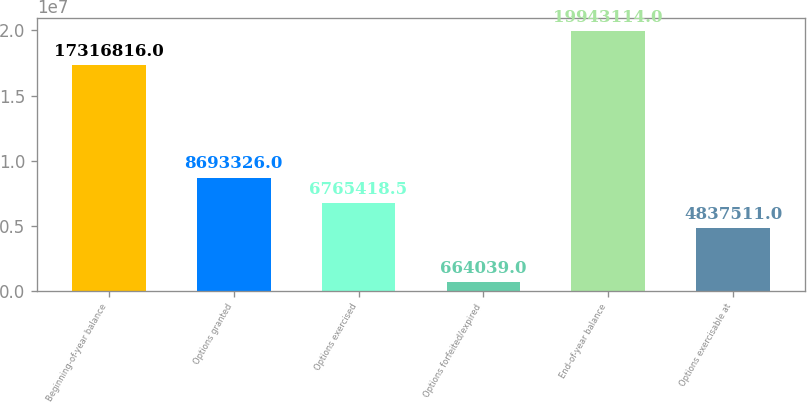<chart> <loc_0><loc_0><loc_500><loc_500><bar_chart><fcel>Beginning-of-year balance<fcel>Options granted<fcel>Options exercised<fcel>Options forfeited/expired<fcel>End-of-year balance<fcel>Options exercisable at<nl><fcel>1.73168e+07<fcel>8.69333e+06<fcel>6.76542e+06<fcel>664039<fcel>1.99431e+07<fcel>4.83751e+06<nl></chart> 